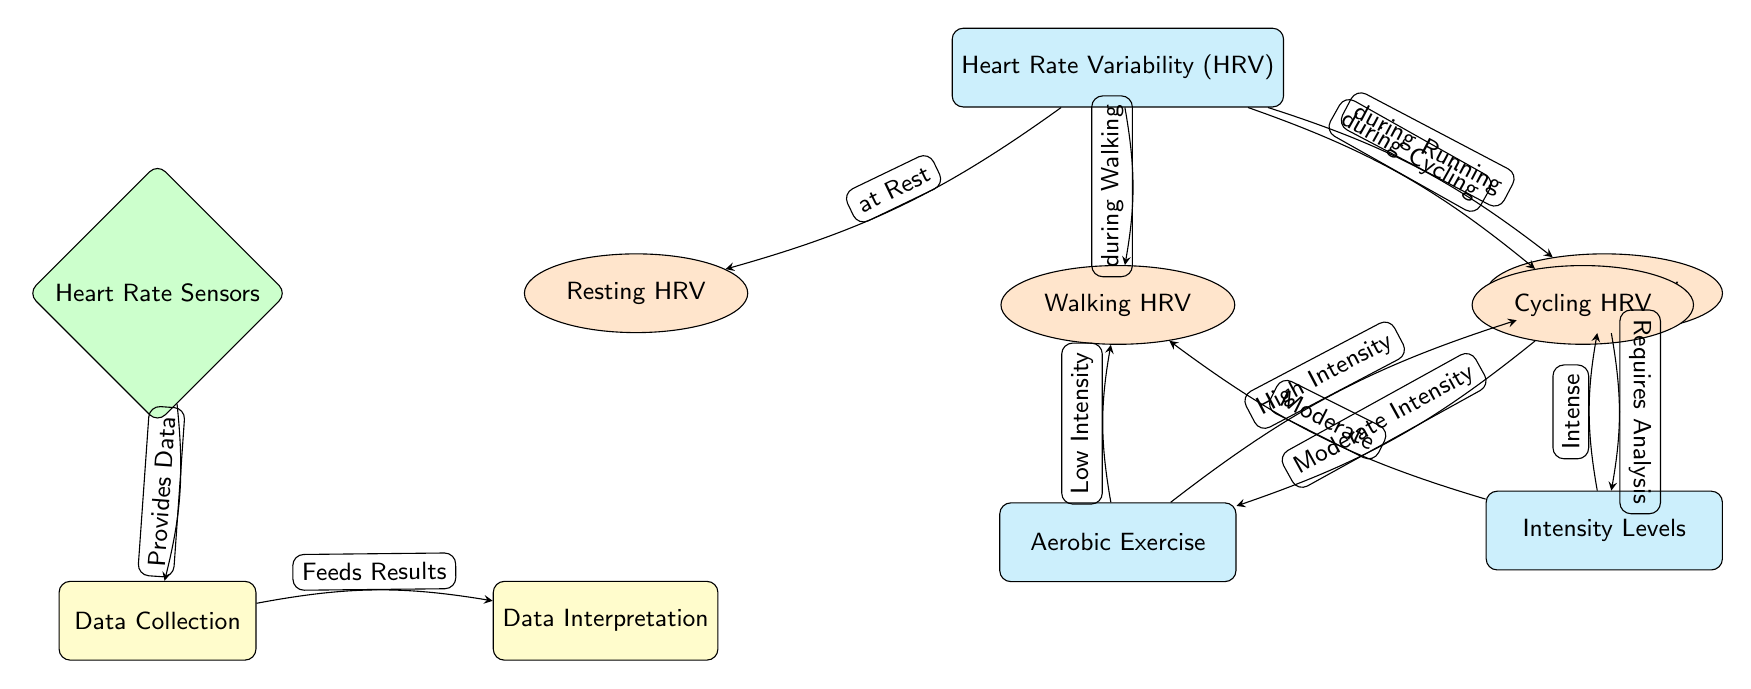What type of data do heart rate sensors provide? The diagram indicates that heart rate sensors provide data that is then collected for analysis. This is shown by the edge connecting the sensor node to the data collection node, indicating a direct relationship.
Answer: Data How many activities are represented in the diagram? There are four distinct activities listed in the diagram: Resting HRV, Walking HRV, Running HRV, and Cycling HRV. These nodes are directly connected to the main HRV node, indicating their relationship to heart rate variability measurements during different activities. Counting these nodes gives us the total.
Answer: Four Which activity is linked to low intensity? The diagram shows that Walking HRV is linked to Aerobic Exercise under Low Intensity. The connection from aerobic exercise to walking connects these two nodes directly, indicating the type of intensity associated with each activity.
Answer: Walking HRV What requires analysis in the context of this diagram? The diagram indicates that Running HRV requires analysis, as shown by the edge connecting the running activity node to the intensity levels node, indicating that running is a condition that is analyzed regarding intensity levels.
Answer: Running HRV What type of exercise is associated with cycling in the diagram? In the diagram, Cycling HRV is directly associated with Aerobic Exercise and labeled as Moderate Intensity. The connection from the cycling activity node to the aerobic exercise node demonstrates this relationship.
Answer: Moderate Intensity What is the relationship between data collection and interpretation? The diagram indicates a direct relationship where data collection feeds results into data interpretation. This is shown by the arrow connecting the data collection node to the data interpretation node, demonstrating the flow of information.
Answer: Feeds Results 